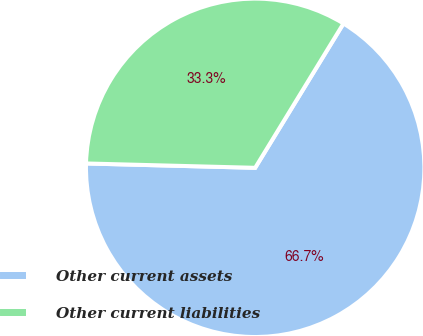Convert chart to OTSL. <chart><loc_0><loc_0><loc_500><loc_500><pie_chart><fcel>Other current assets<fcel>Other current liabilities<nl><fcel>66.67%<fcel>33.33%<nl></chart> 